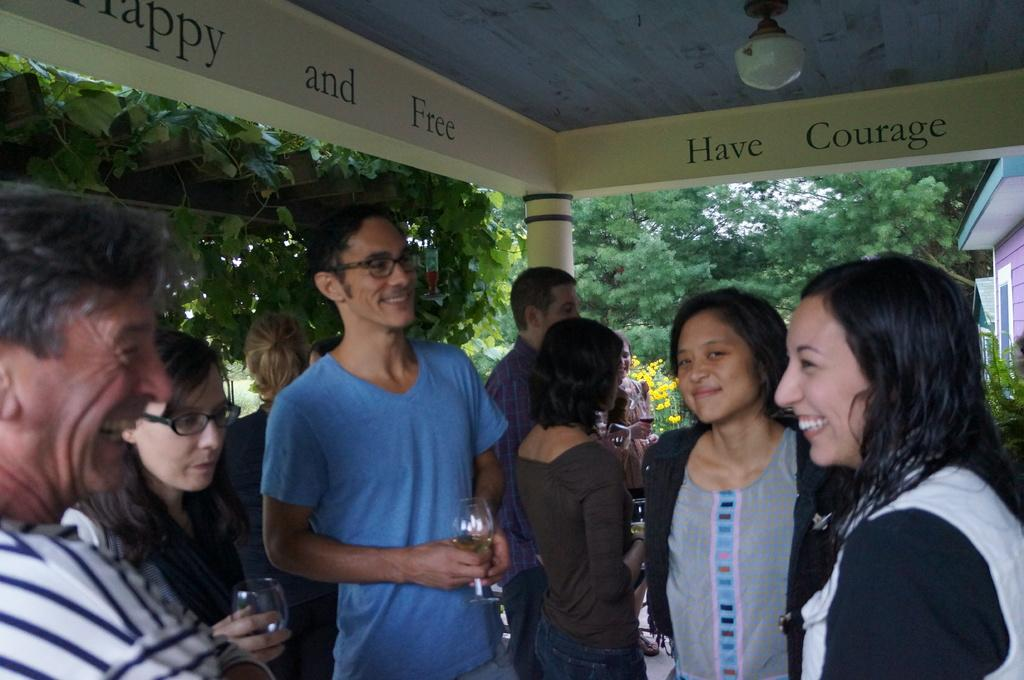What is the main subject of the image? The main subject of the image is a group of people. What are the people holding in their hands? Most of the people are holding glasses in their hands. Where are the people standing in the image? The people are standing under a roof. What can be seen in the background of the image? There are many trees in the background of the image. How many tickets are visible in the image? There are no tickets present in the image. What type of office can be seen in the background of the image? There is no office visible in the image; it features a group of people standing under a roof with many trees in the background. 